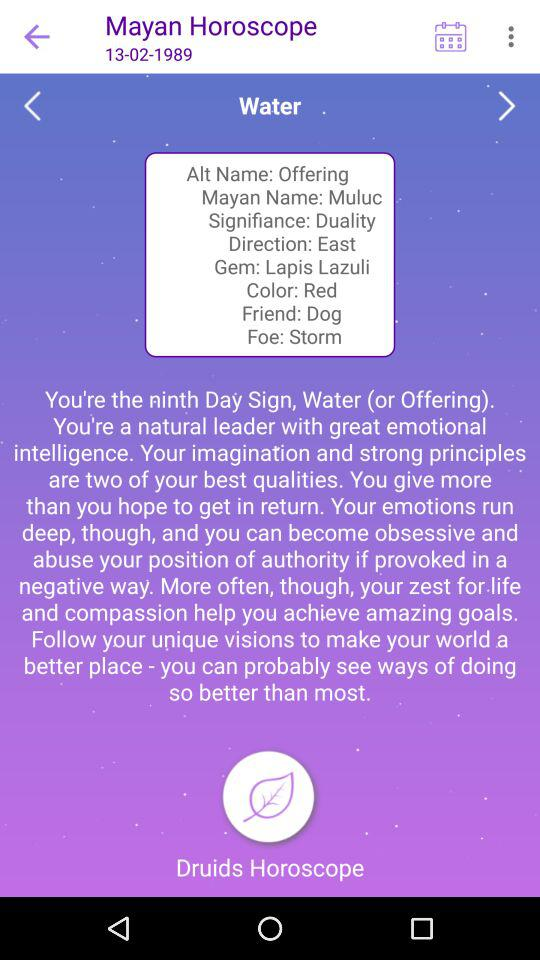What is the direction shown? The direction shown is "East". 